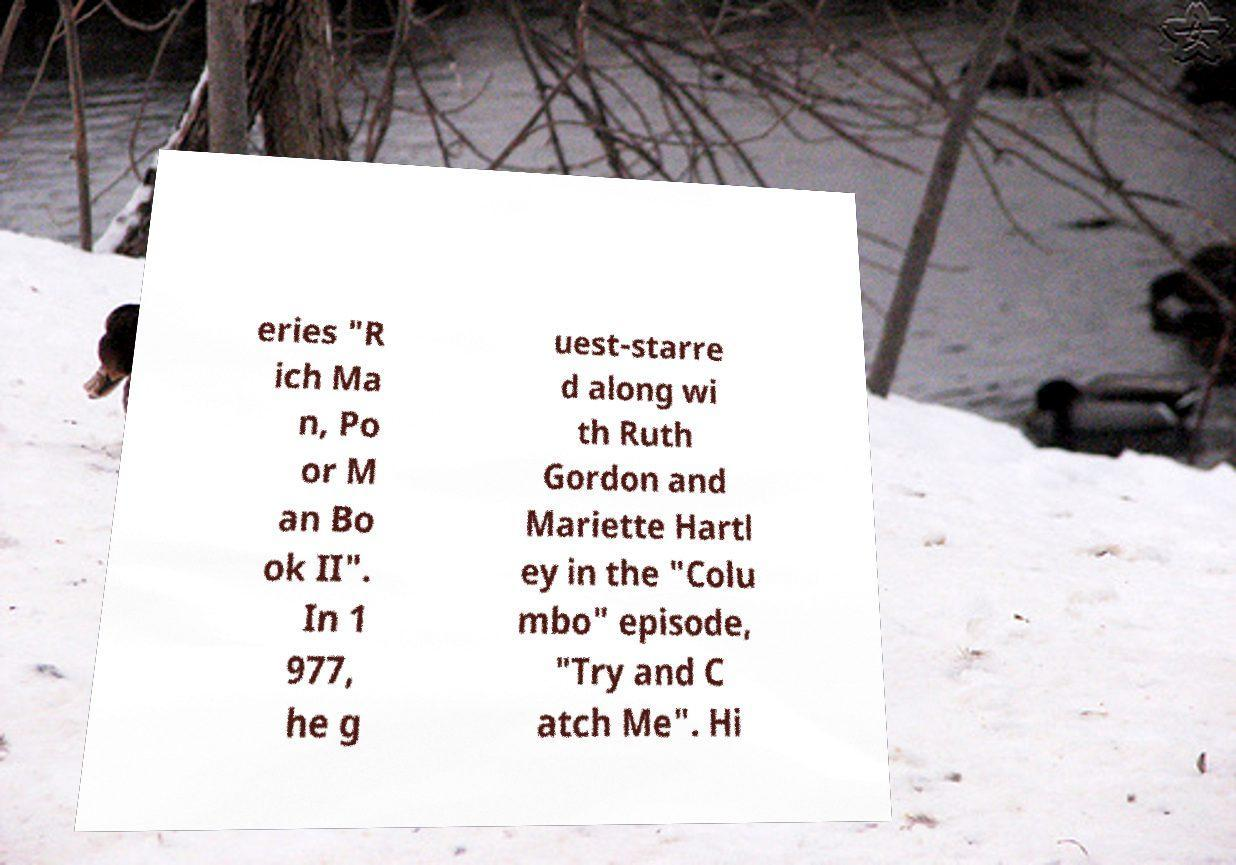Can you read and provide the text displayed in the image?This photo seems to have some interesting text. Can you extract and type it out for me? eries "R ich Ma n, Po or M an Bo ok II". In 1 977, he g uest-starre d along wi th Ruth Gordon and Mariette Hartl ey in the "Colu mbo" episode, "Try and C atch Me". Hi 